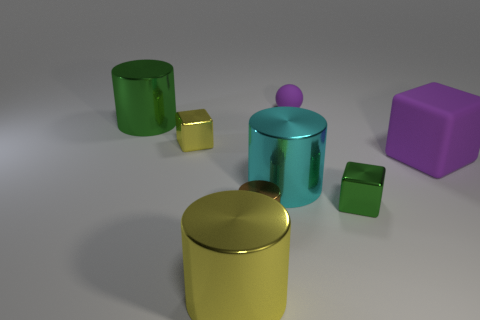Subtract all tiny yellow cubes. How many cubes are left? 2 Subtract 2 cylinders. How many cylinders are left? 2 Subtract all yellow cylinders. How many cylinders are left? 3 Add 1 small objects. How many objects exist? 9 Subtract all blocks. How many objects are left? 5 Add 6 big purple cubes. How many big purple cubes are left? 7 Add 7 metallic blocks. How many metallic blocks exist? 9 Subtract 1 brown cylinders. How many objects are left? 7 Subtract all red spheres. Subtract all brown cubes. How many spheres are left? 1 Subtract all tiny brown shiny objects. Subtract all small yellow metal objects. How many objects are left? 6 